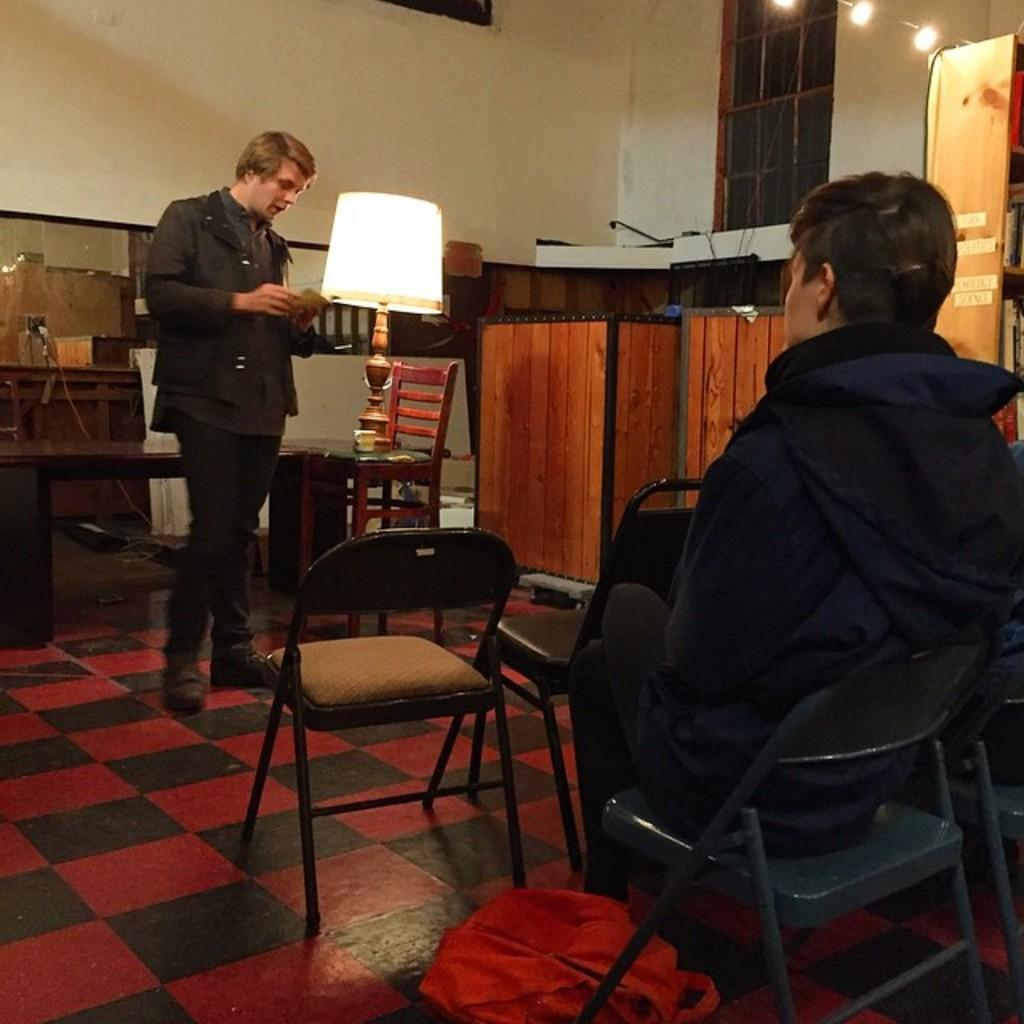What is the position of the person on the right side of the image? There is a person sitting in a chair on the right side of the image. What is the standing person doing in the image? The standing person is looking into a book. Can you describe the lighting in the image? There is a lamp beside the standing person, which suggests that it provides light. How many people are present in the image? There are two people in the image, one sitting and one standing. What type of goose can be seen on the back of the sitting person in the image? There is no goose present in the image, and the sitting person's back is not visible. Is there a turkey in the image? There is no turkey present in the image. 